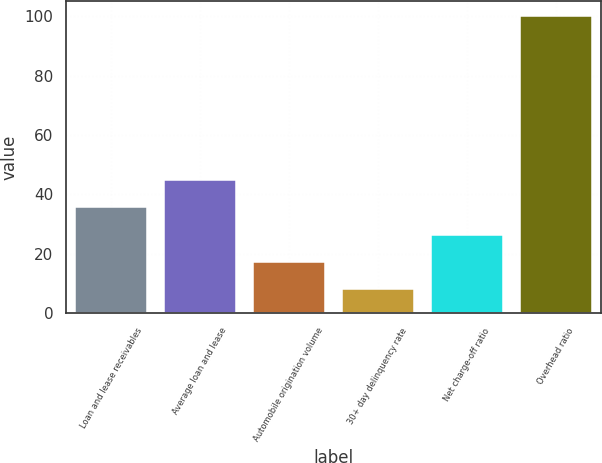Convert chart to OTSL. <chart><loc_0><loc_0><loc_500><loc_500><bar_chart><fcel>Loan and lease receivables<fcel>Average loan and lease<fcel>Automobile origination volume<fcel>30+ day delinquency rate<fcel>Net charge-off ratio<fcel>Overhead ratio<nl><fcel>35.6<fcel>44.8<fcel>17.2<fcel>8<fcel>26.4<fcel>100<nl></chart> 